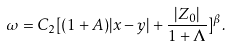<formula> <loc_0><loc_0><loc_500><loc_500>\omega = C _ { 2 } [ ( 1 + A ) | x - y | + \frac { | Z _ { 0 } | } { 1 + \Lambda } ] ^ { \beta } .</formula> 